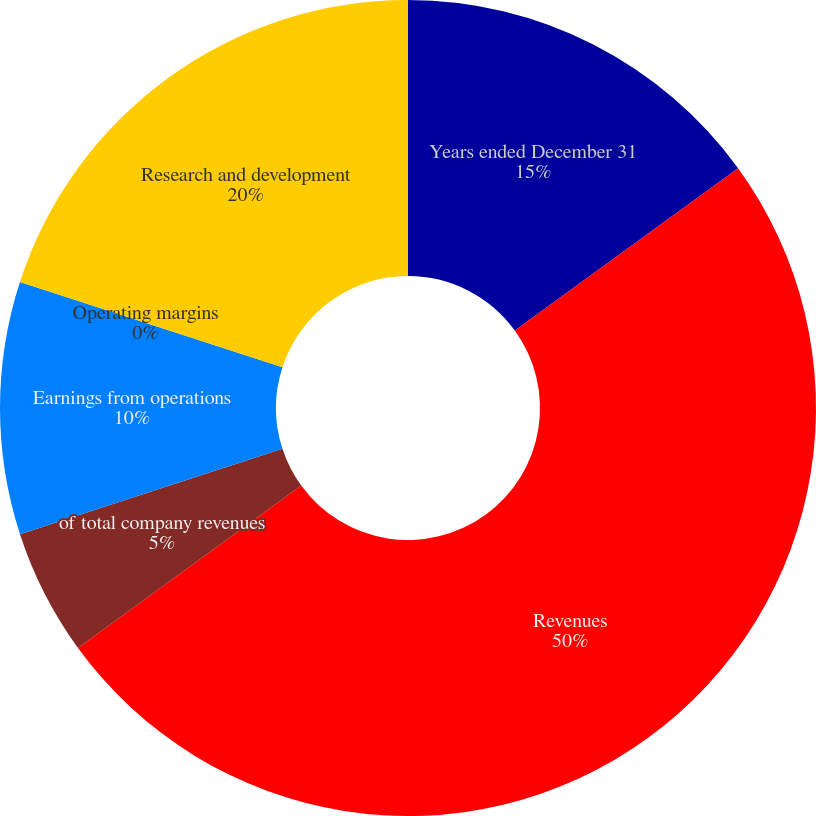Convert chart to OTSL. <chart><loc_0><loc_0><loc_500><loc_500><pie_chart><fcel>Years ended December 31<fcel>Revenues<fcel>of total company revenues<fcel>Earnings from operations<fcel>Operating margins<fcel>Research and development<nl><fcel>15.0%<fcel>49.99%<fcel>5.0%<fcel>10.0%<fcel>0.0%<fcel>20.0%<nl></chart> 